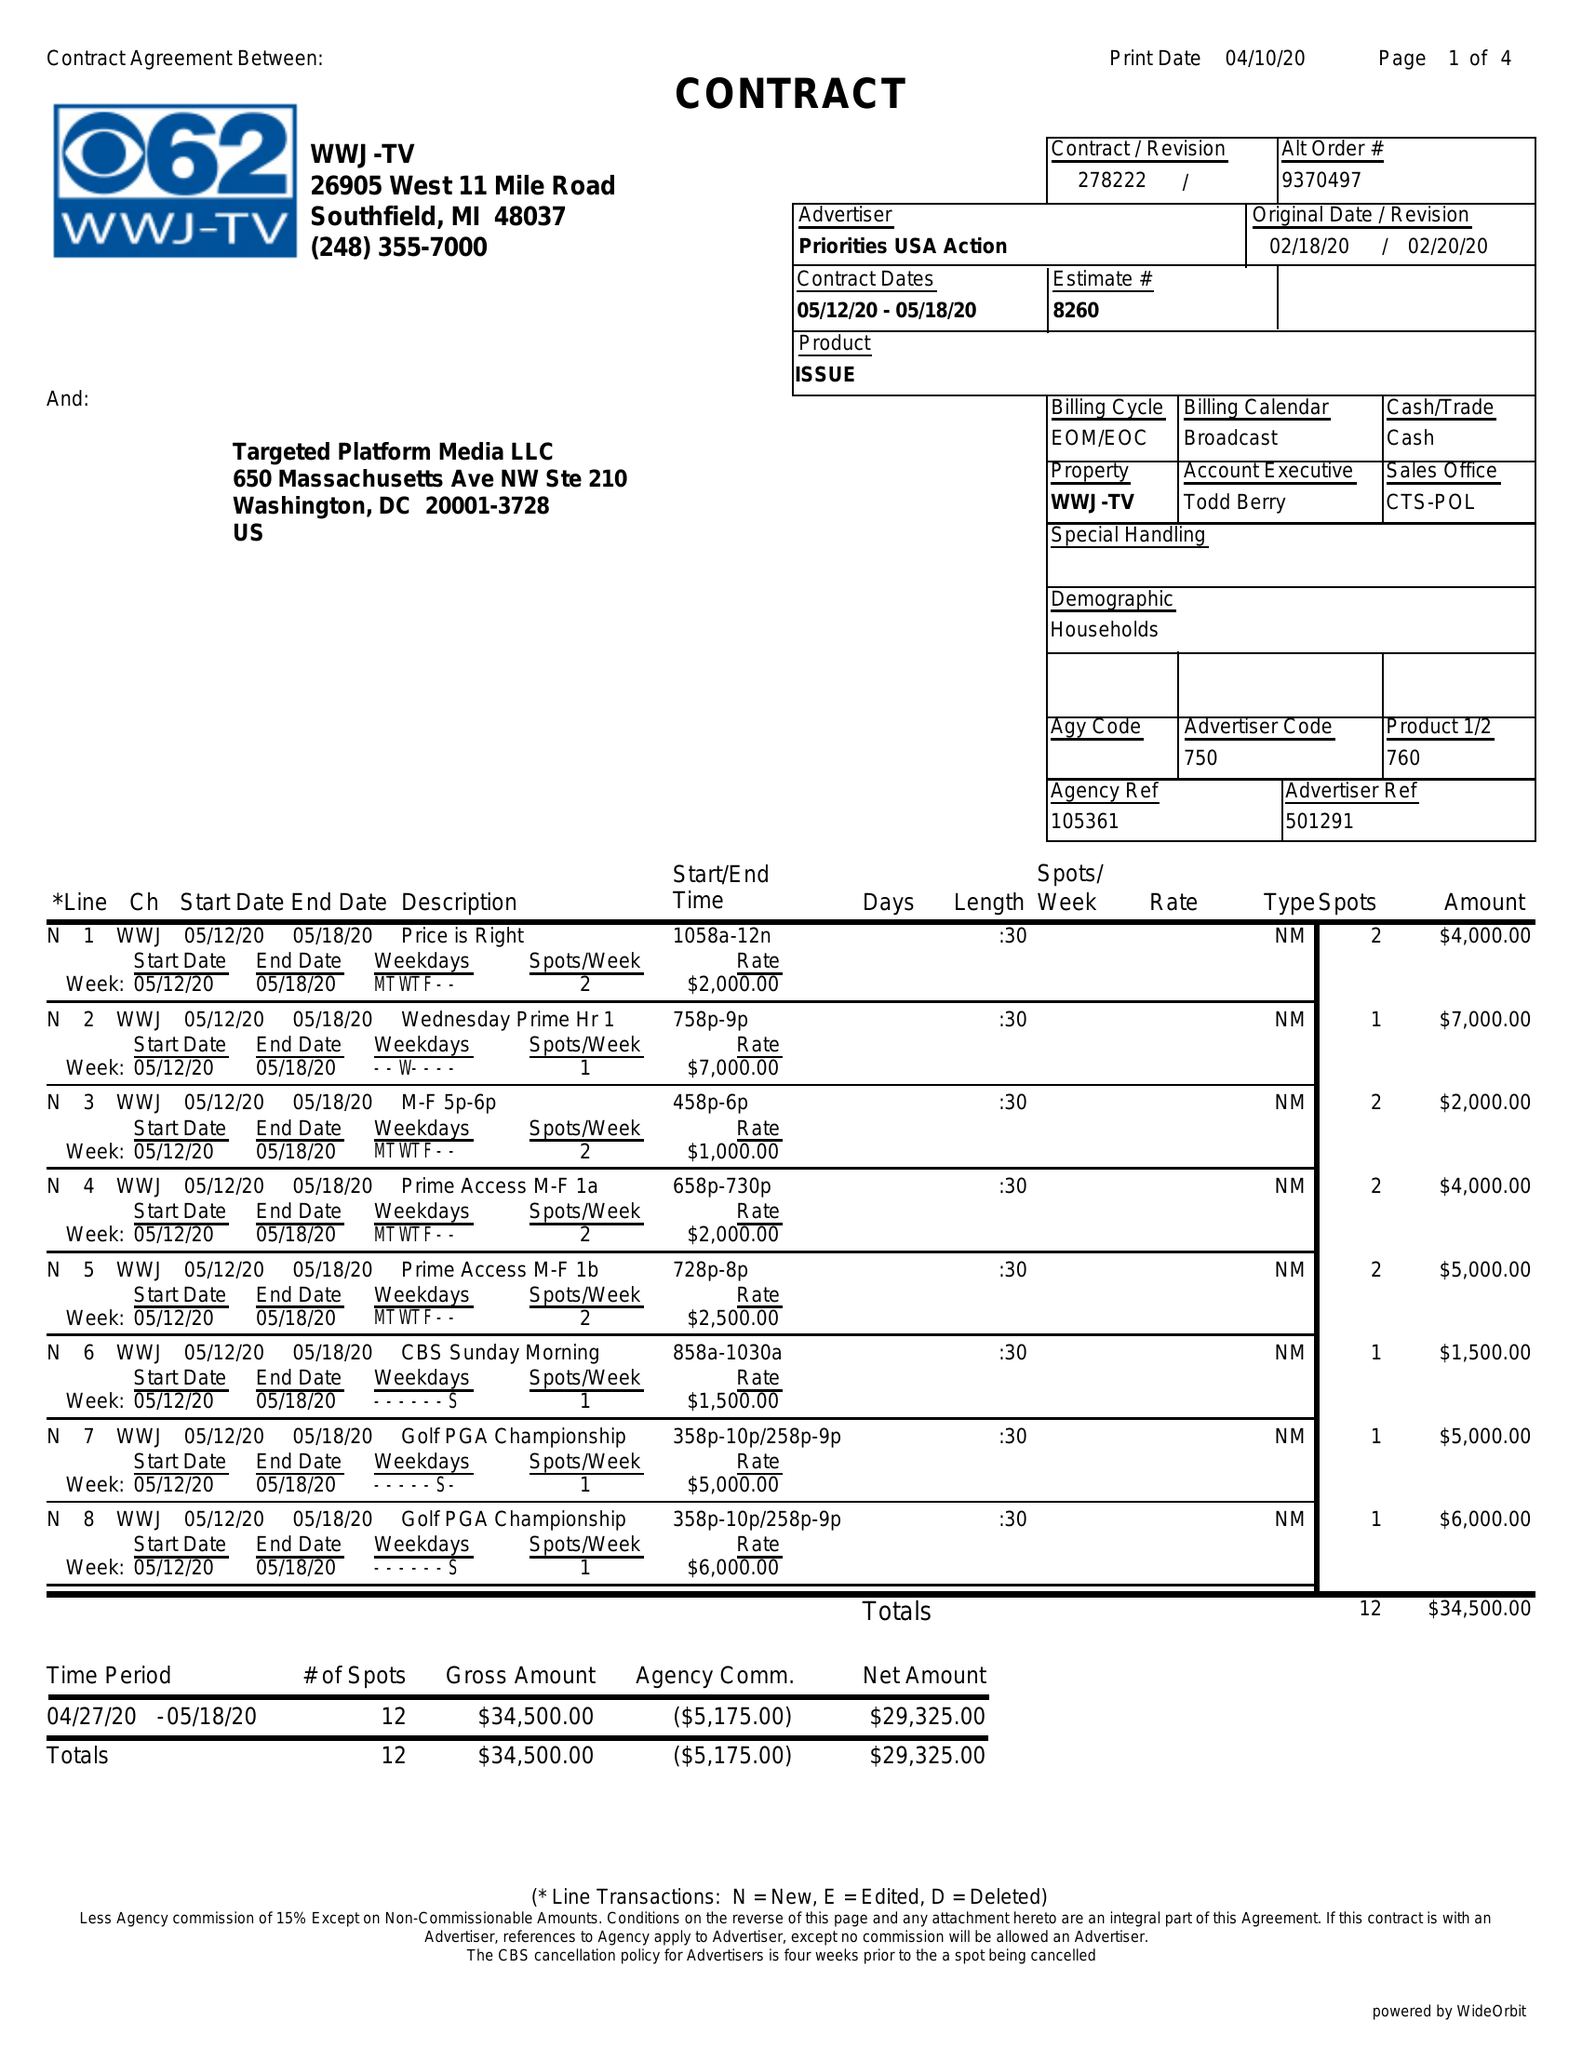What is the value for the flight_to?
Answer the question using a single word or phrase. 05/18/20 